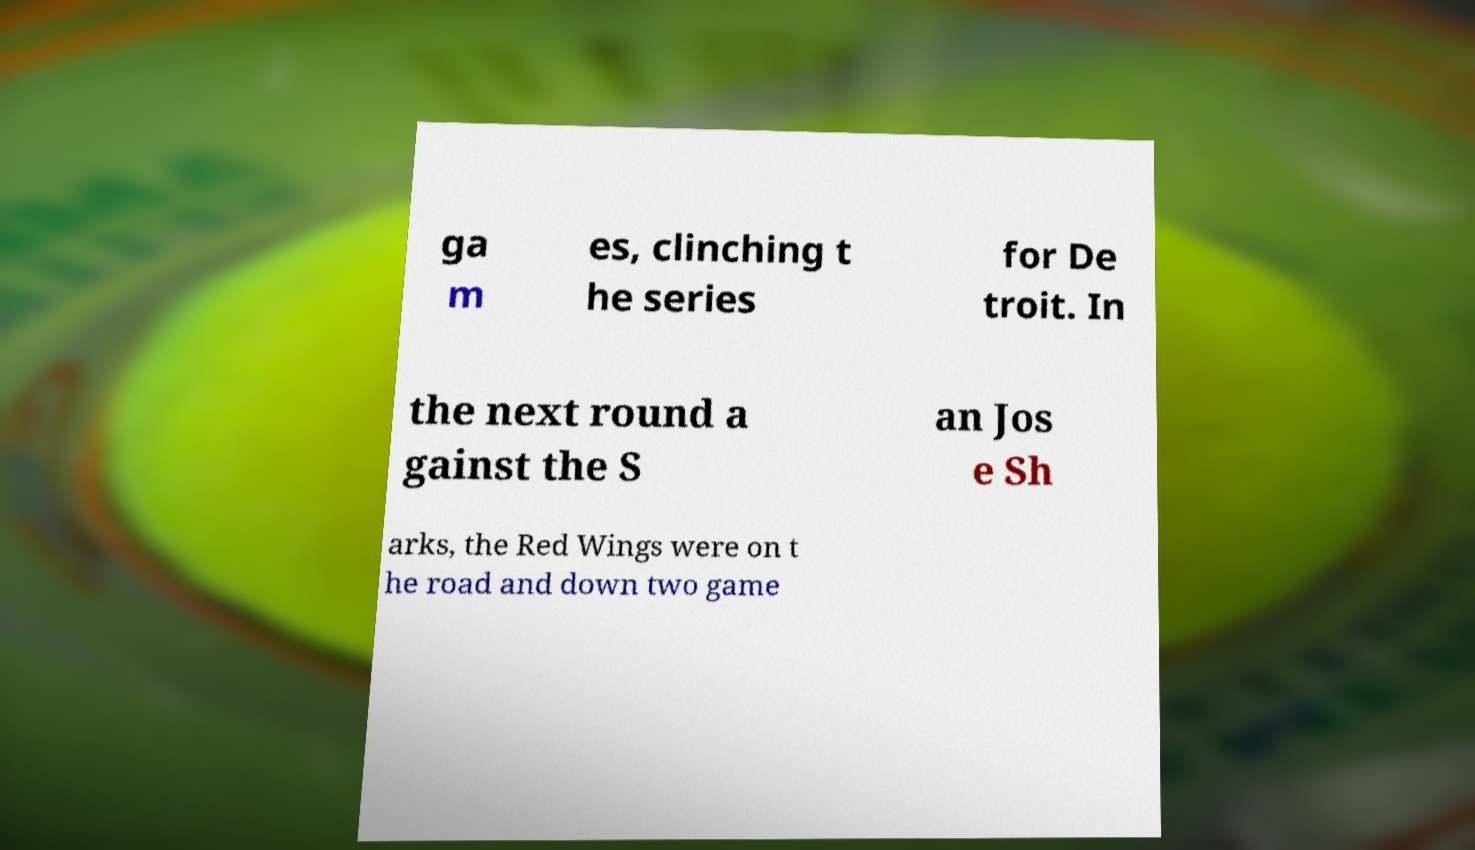Can you accurately transcribe the text from the provided image for me? ga m es, clinching t he series for De troit. In the next round a gainst the S an Jos e Sh arks, the Red Wings were on t he road and down two game 